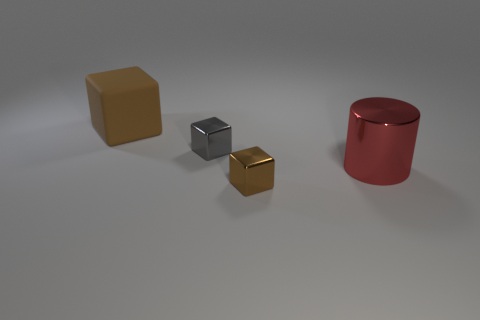There is a gray shiny block; is its size the same as the brown cube that is behind the small gray metal object? No, the gray shiny block is not the same size as the brown cube behind it. It appears smaller and is positioned closer to the foreground, thus making a direct size comparison challenging without additional perspective. However, by estimating the dimensions relative to nearby objects, it's clear that the brown cube is larger. 